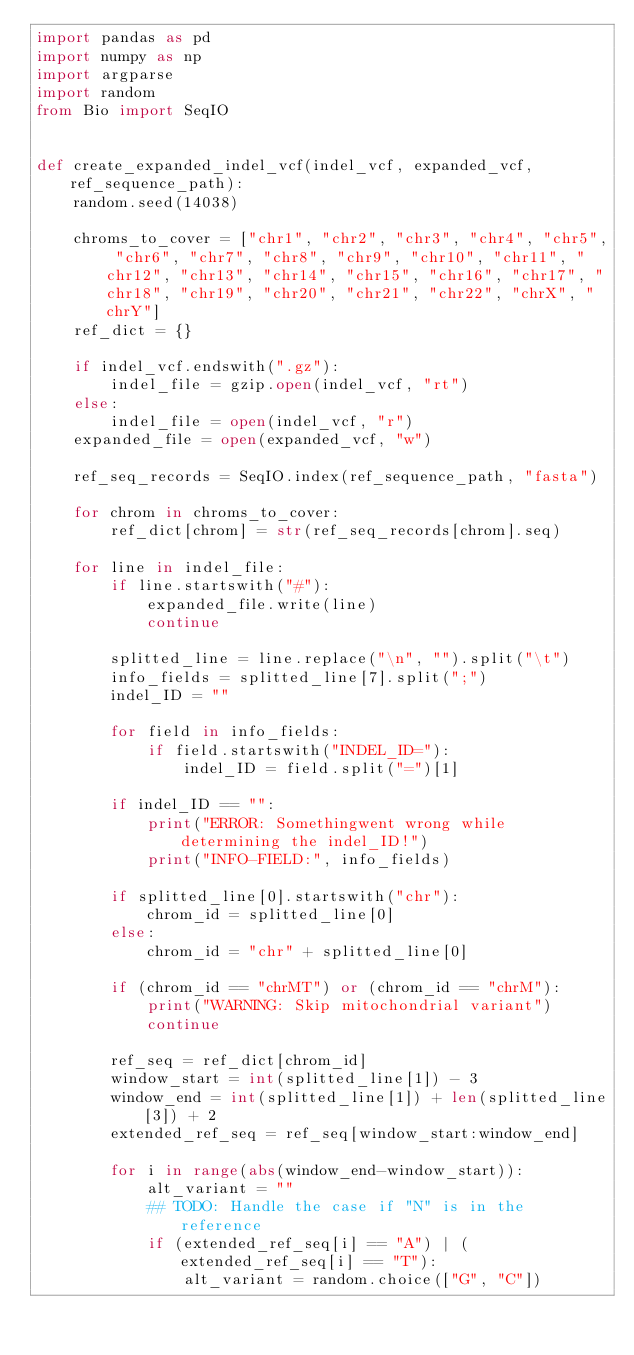<code> <loc_0><loc_0><loc_500><loc_500><_Python_>import pandas as pd
import numpy as np
import argparse
import random
from Bio import SeqIO


def create_expanded_indel_vcf(indel_vcf, expanded_vcf, ref_sequence_path):
    random.seed(14038)
    
    chroms_to_cover = ["chr1", "chr2", "chr3", "chr4", "chr5", "chr6", "chr7", "chr8", "chr9", "chr10", "chr11", "chr12", "chr13", "chr14", "chr15", "chr16", "chr17", "chr18", "chr19", "chr20", "chr21", "chr22", "chrX", "chrY"]
    ref_dict = {}
    
    if indel_vcf.endswith(".gz"):
        indel_file = gzip.open(indel_vcf, "rt")
    else:
        indel_file = open(indel_vcf, "r")
    expanded_file = open(expanded_vcf, "w")

    ref_seq_records = SeqIO.index(ref_sequence_path, "fasta")

    for chrom in chroms_to_cover:
        ref_dict[chrom] = str(ref_seq_records[chrom].seq)

    for line in indel_file:
        if line.startswith("#"):
            expanded_file.write(line)
            continue
        
        splitted_line = line.replace("\n", "").split("\t")
        info_fields = splitted_line[7].split(";")
        indel_ID = ""
        
        for field in info_fields:
            if field.startswith("INDEL_ID="):
                indel_ID = field.split("=")[1]
        
        if indel_ID == "":
            print("ERROR: Somethingwent wrong while determining the indel_ID!")
            print("INFO-FIELD:", info_fields)

        if splitted_line[0].startswith("chr"):
            chrom_id = splitted_line[0]
        else:
            chrom_id = "chr" + splitted_line[0]

        if (chrom_id == "chrMT") or (chrom_id == "chrM"):
            print("WARNING: Skip mitochondrial variant")
            continue

        ref_seq = ref_dict[chrom_id]
        window_start = int(splitted_line[1]) - 3
        window_end = int(splitted_line[1]) + len(splitted_line[3]) + 2
        extended_ref_seq = ref_seq[window_start:window_end]

        for i in range(abs(window_end-window_start)):
            alt_variant = ""
            ## TODO: Handle the case if "N" is in the reference
            if (extended_ref_seq[i] == "A") | (extended_ref_seq[i] == "T"):
                alt_variant = random.choice(["G", "C"])</code> 